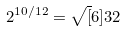<formula> <loc_0><loc_0><loc_500><loc_500>2 ^ { 1 0 / 1 2 } = \sqrt { [ } 6 ] { 3 2 }</formula> 